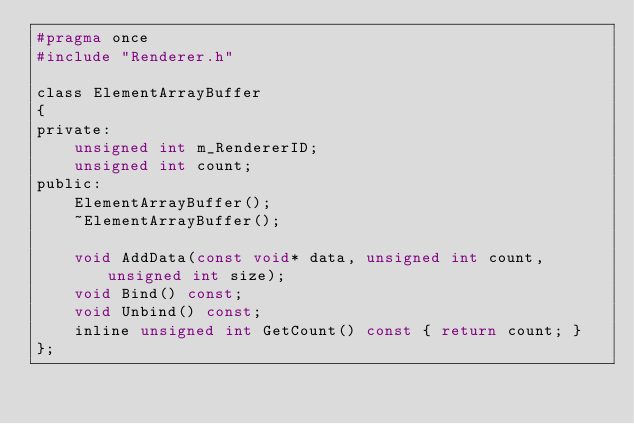Convert code to text. <code><loc_0><loc_0><loc_500><loc_500><_C_>#pragma once
#include "Renderer.h"

class ElementArrayBuffer
{
private:
	unsigned int m_RendererID;
	unsigned int count;
public:
	ElementArrayBuffer();
	~ElementArrayBuffer();

	void AddData(const void* data, unsigned int count, unsigned int size);
	void Bind() const;
	void Unbind() const;
	inline unsigned int GetCount() const { return count; }
};
</code> 